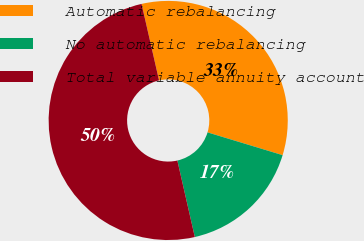<chart> <loc_0><loc_0><loc_500><loc_500><pie_chart><fcel>Automatic rebalancing<fcel>No automatic rebalancing<fcel>Total variable annuity account<nl><fcel>33.26%<fcel>16.74%<fcel>50.0%<nl></chart> 